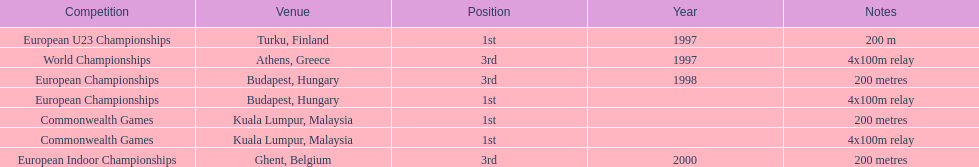In what year between 1997 and 2000 did julian golding, the sprinter representing the united kingdom and england finish first in both the 4 x 100 m relay and the 200 metres race? 1998. 